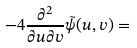Convert formula to latex. <formula><loc_0><loc_0><loc_500><loc_500>- 4 \frac { \partial ^ { 2 } } { \partial u \partial v } \tilde { \psi } ( u , v ) =</formula> 